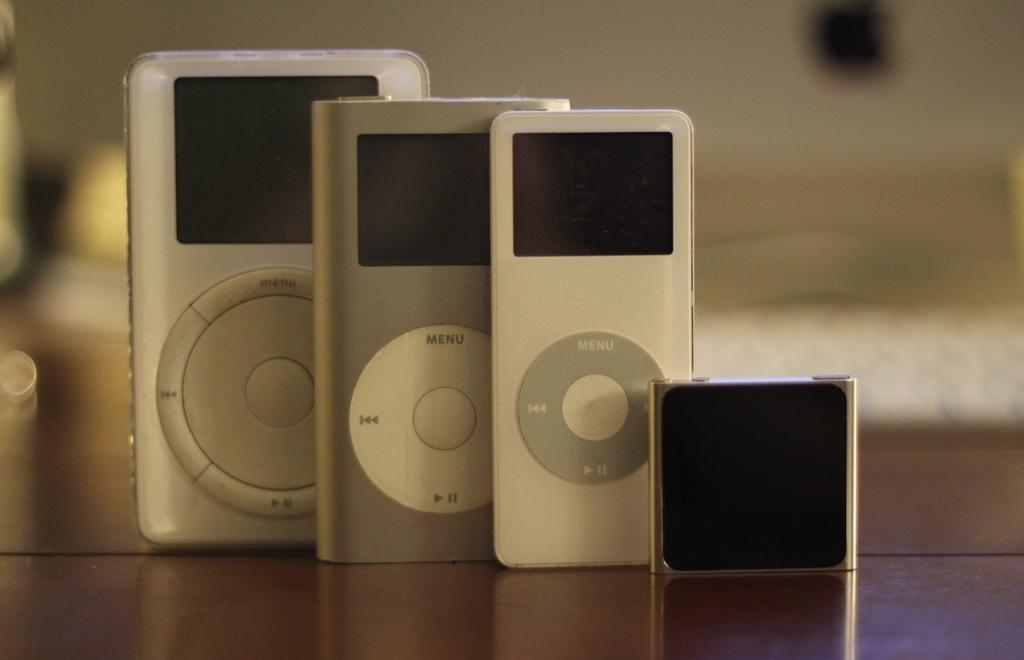<image>
Present a compact description of the photo's key features. Four devices next to one another and all with the Menu button on top. 